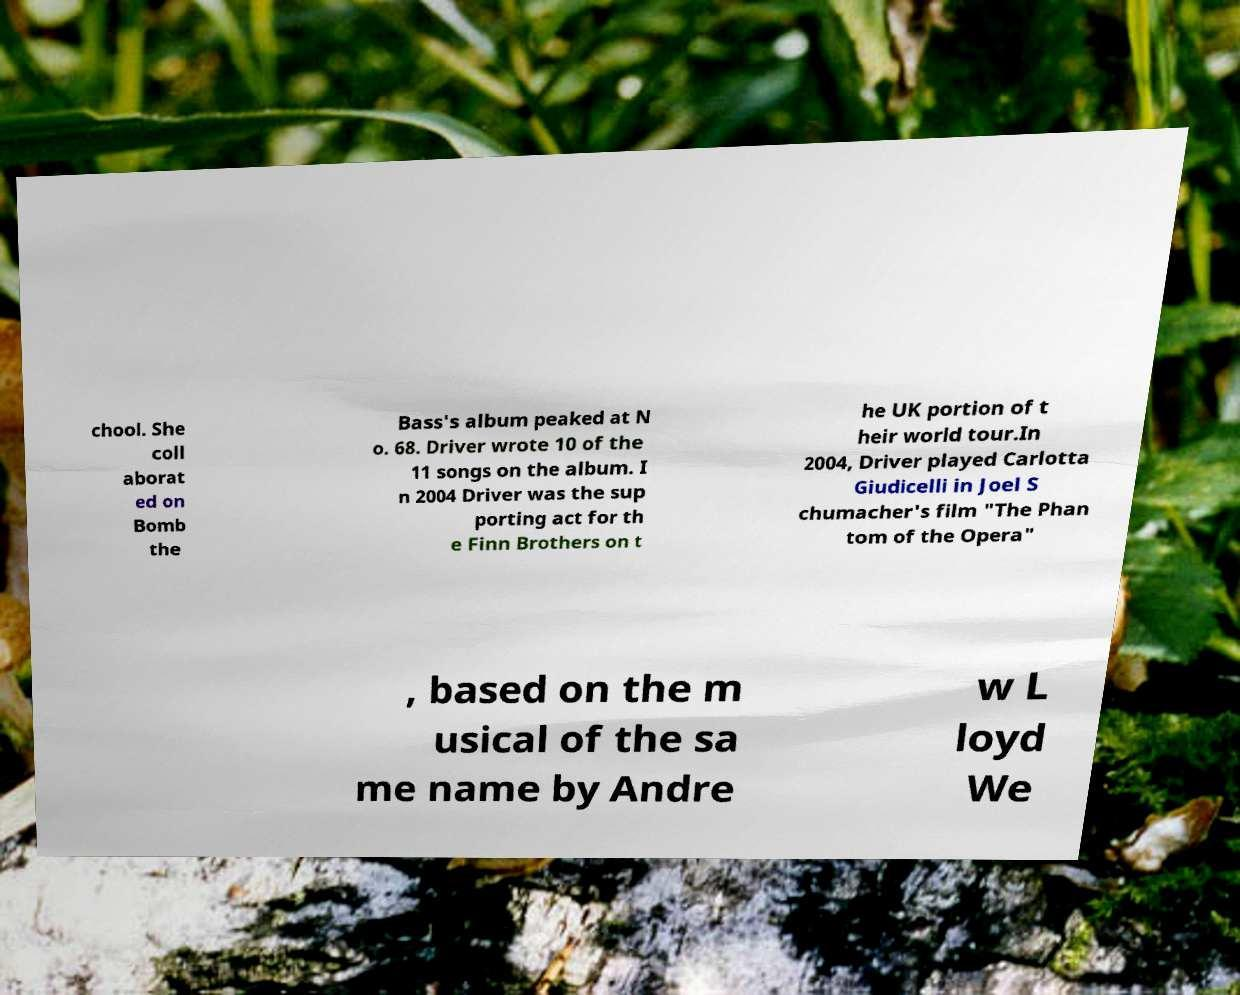Could you extract and type out the text from this image? chool. She coll aborat ed on Bomb the Bass's album peaked at N o. 68. Driver wrote 10 of the 11 songs on the album. I n 2004 Driver was the sup porting act for th e Finn Brothers on t he UK portion of t heir world tour.In 2004, Driver played Carlotta Giudicelli in Joel S chumacher's film "The Phan tom of the Opera" , based on the m usical of the sa me name by Andre w L loyd We 